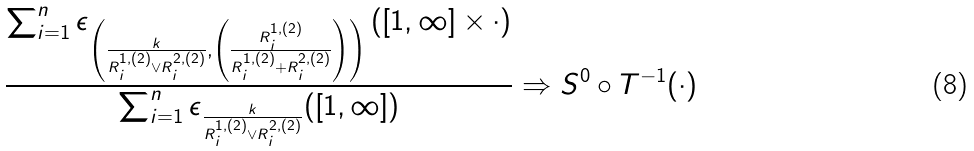Convert formula to latex. <formula><loc_0><loc_0><loc_500><loc_500>\frac { \sum _ { i = 1 } ^ { n } \epsilon _ { \left ( \frac { k } { R ^ { 1 , ( 2 ) } _ { i } \vee R ^ { 2 , ( 2 ) } _ { i } } , \left ( \frac { R ^ { 1 , ( 2 ) } _ { i } } { R ^ { 1 , ( 2 ) } _ { i } + R ^ { 2 , ( 2 ) } _ { i } } \right ) \right ) } \left ( [ 1 , \infty ] \times \cdot \right ) } { \sum _ { i = 1 } ^ { n } \epsilon _ { \frac { k } { R ^ { 1 , ( 2 ) } _ { i } \vee R ^ { 2 , ( 2 ) } _ { i } } } ( [ 1 , \infty ] ) } \Rightarrow S ^ { 0 } \circ T ^ { - 1 } ( \cdot )</formula> 